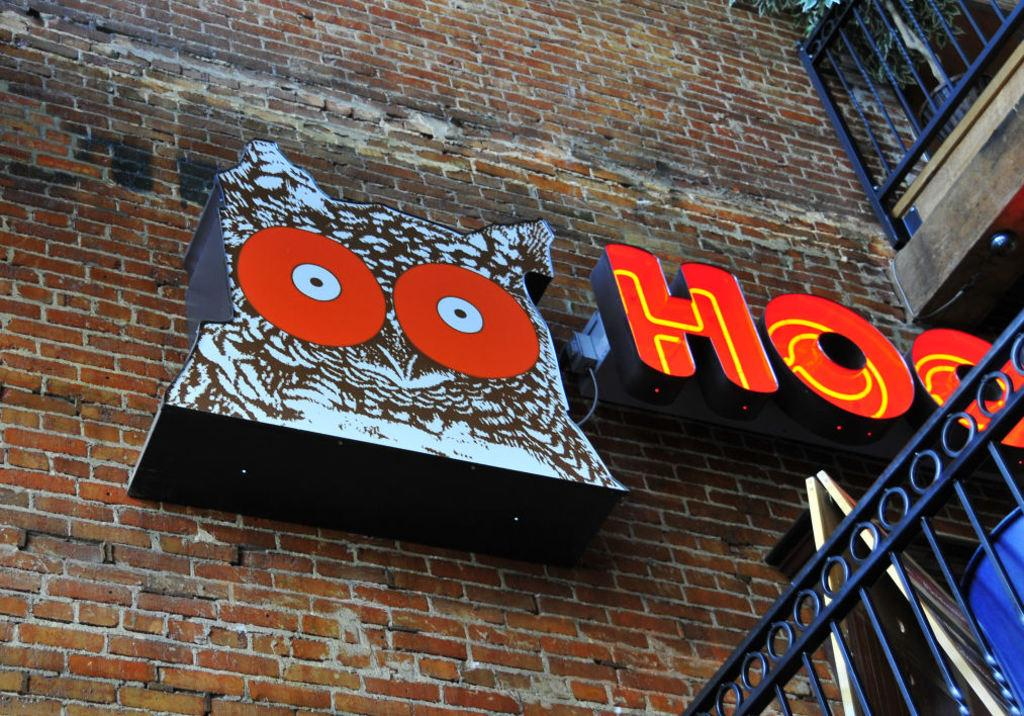<image>
Give a short and clear explanation of the subsequent image. A sign for Hooters shows an Owl on a brick wall. 